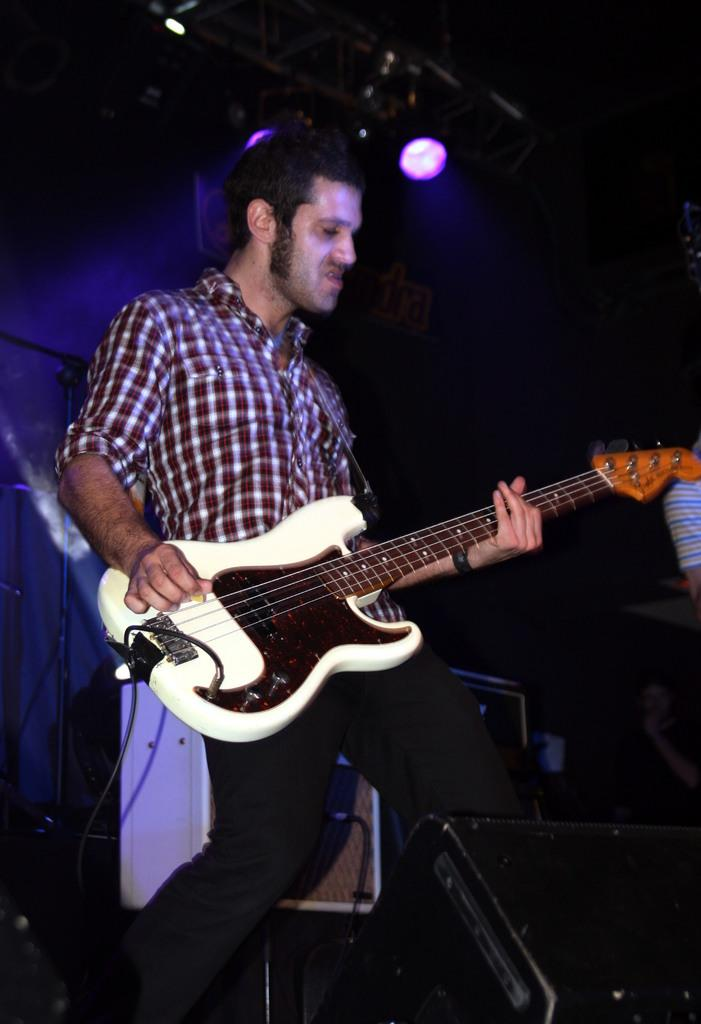What is the man in the image doing? The man is playing the guitar. What is the man holding in the image? The man is holding a guitar. Can you describe the setting of the image? There is a roof with lights in the image, and there is a speaker at the bottom of the image. Are there any visible wires in the image? Yes, there are wires visible in the image. What type of plantation can be seen in the image? There is no plantation present in the image. What material is the man's linen made of in the image? The image does not provide information about the material of the man's clothing. 